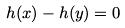Convert formula to latex. <formula><loc_0><loc_0><loc_500><loc_500>h ( x ) - h ( y ) = 0</formula> 